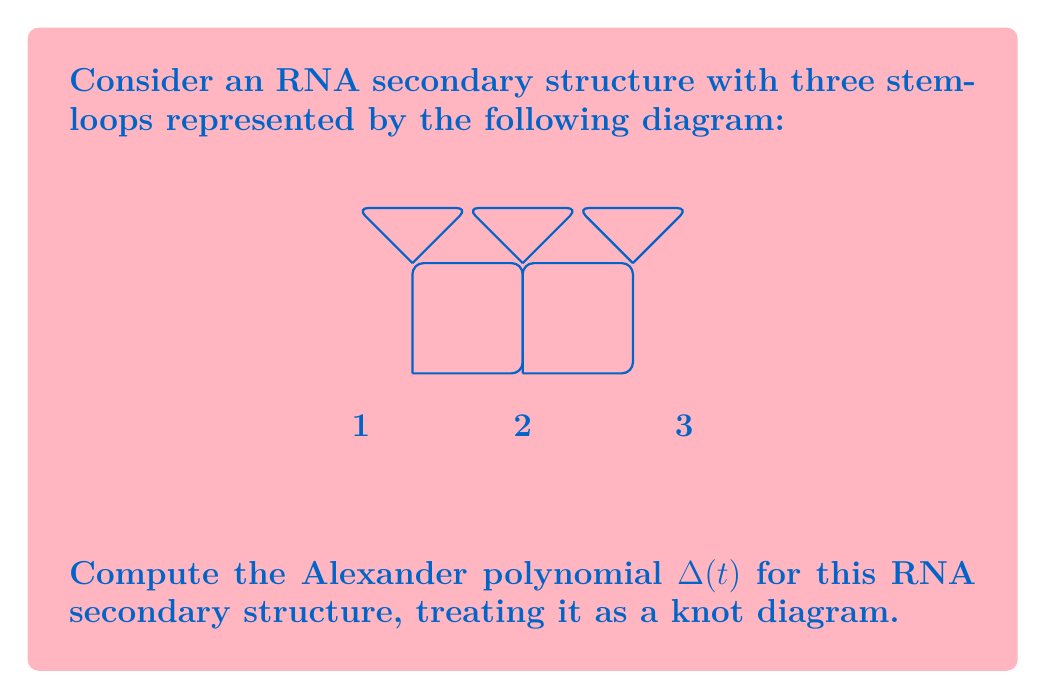Solve this math problem. To compute the Alexander polynomial for this RNA secondary structure, we'll follow these steps:

1) First, we need to create a Seifert matrix for the structure. The Seifert matrix $V$ is constructed based on the linking numbers of the Seifert circles in the diagram.

2) For this structure, we have three Seifert circles (one for each stem-loop). Let's number them 1, 2, and 3 from left to right.

3) The Seifert matrix $V$ will be a 3x3 matrix. The entry $V_{ij}$ is the linking number of the i-th Seifert circle with the j-th Seifert circle, considering the orientation.

4) In this case, the Seifert matrix is:

   $$V = \begin{pmatrix}
   1 & -1 & 0 \\
   0 & 1 & -1 \\
   0 & 0 & 1
   \end{pmatrix}$$

5) The Alexander polynomial is then computed as:

   $$\Delta(t) = \det(tV - V^T)$$

   where $V^T$ is the transpose of $V$.

6) Calculating $tV - V^T$:

   $$tV - V^T = \begin{pmatrix}
   t-1 & -t & 0 \\
   1 & t-1 & -t \\
   0 & 1 & t-1
   \end{pmatrix}$$

7) Now we need to calculate the determinant of this matrix:

   $$\det(tV - V^T) = (t-1)((t-1)(t-1) - (-t)(1)) - (-t)(1(t-1) - 0)$$

8) Simplifying:

   $$\Delta(t) = (t-1)(t^2 - 2t + 1 + t) - t(t-1)$$
   $$= (t-1)(t^2 - t + 1) - t(t-1)$$
   $$= t^3 - t^2 + t - t^2 + t - 1 - t^2 + t$$
   $$= t^3 - 3t^2 + 3t - 1$$

Therefore, the Alexander polynomial for this RNA secondary structure is $t^3 - 3t^2 + 3t - 1$.
Answer: $\Delta(t) = t^3 - 3t^2 + 3t - 1$ 